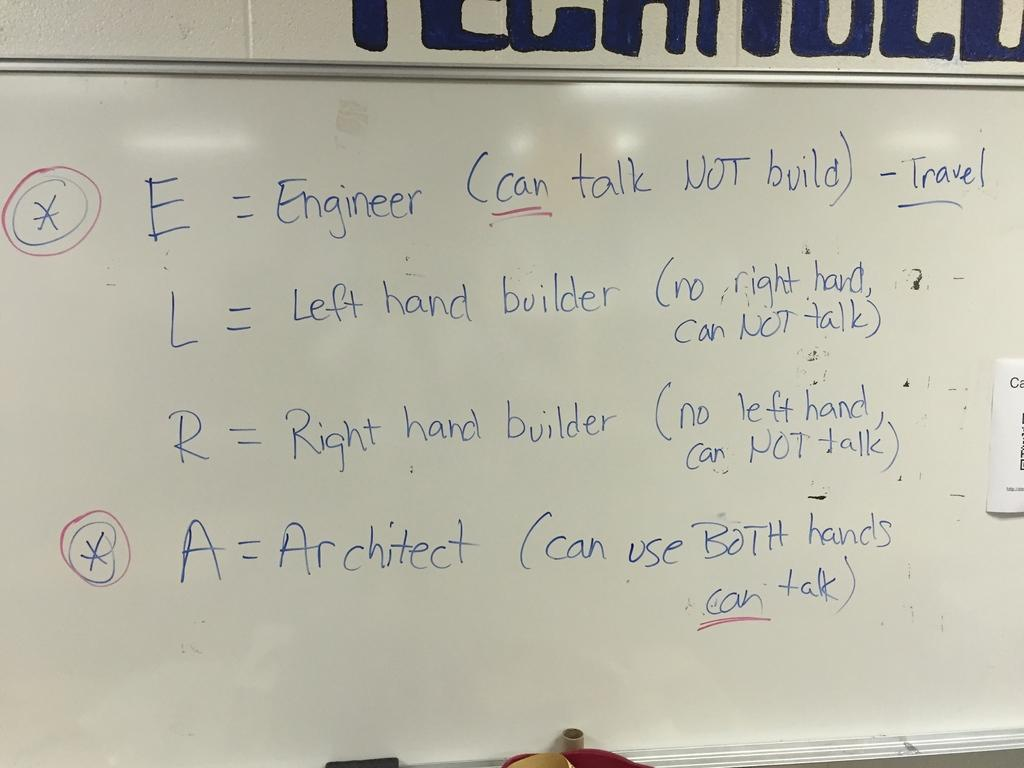<image>
Present a compact description of the photo's key features. a close up of a white board with words E = Engineer on it 